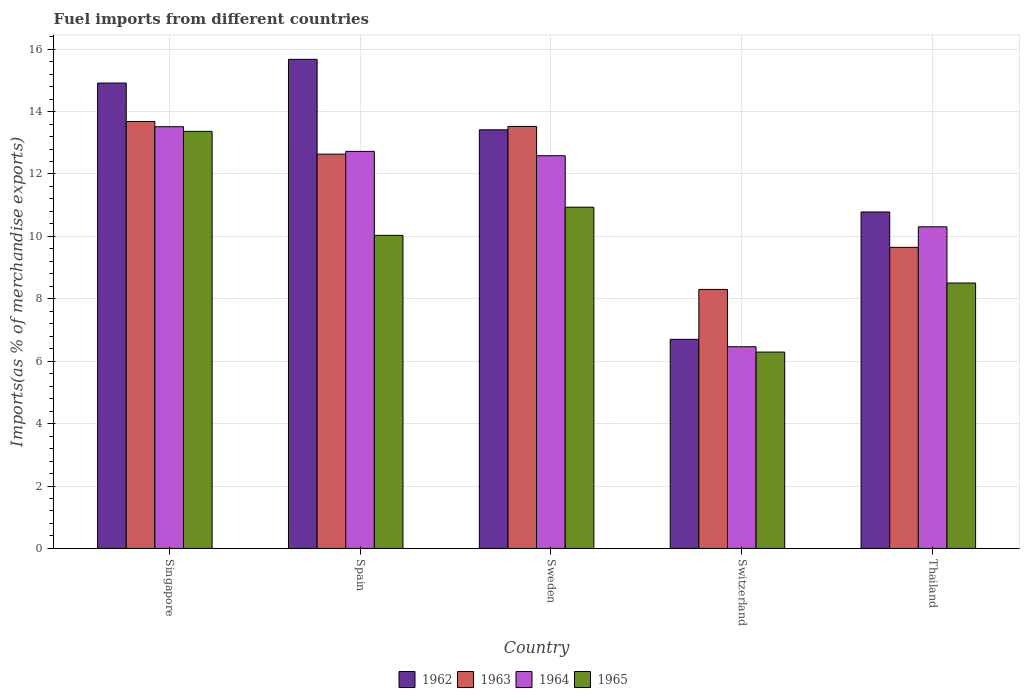How many bars are there on the 2nd tick from the left?
Provide a succinct answer. 4. How many bars are there on the 1st tick from the right?
Provide a succinct answer. 4. What is the label of the 5th group of bars from the left?
Provide a succinct answer. Thailand. What is the percentage of imports to different countries in 1963 in Switzerland?
Provide a succinct answer. 8.3. Across all countries, what is the maximum percentage of imports to different countries in 1965?
Make the answer very short. 13.37. Across all countries, what is the minimum percentage of imports to different countries in 1965?
Your response must be concise. 6.29. In which country was the percentage of imports to different countries in 1965 maximum?
Your response must be concise. Singapore. In which country was the percentage of imports to different countries in 1963 minimum?
Your answer should be compact. Switzerland. What is the total percentage of imports to different countries in 1962 in the graph?
Offer a very short reply. 61.48. What is the difference between the percentage of imports to different countries in 1965 in Switzerland and that in Thailand?
Your answer should be compact. -2.21. What is the difference between the percentage of imports to different countries in 1963 in Singapore and the percentage of imports to different countries in 1964 in Sweden?
Offer a very short reply. 1.1. What is the average percentage of imports to different countries in 1965 per country?
Provide a succinct answer. 9.83. What is the difference between the percentage of imports to different countries of/in 1964 and percentage of imports to different countries of/in 1965 in Spain?
Your answer should be very brief. 2.69. In how many countries, is the percentage of imports to different countries in 1962 greater than 10.8 %?
Provide a succinct answer. 3. What is the ratio of the percentage of imports to different countries in 1962 in Spain to that in Switzerland?
Provide a succinct answer. 2.34. Is the percentage of imports to different countries in 1962 in Sweden less than that in Thailand?
Your response must be concise. No. Is the difference between the percentage of imports to different countries in 1964 in Singapore and Switzerland greater than the difference between the percentage of imports to different countries in 1965 in Singapore and Switzerland?
Provide a succinct answer. No. What is the difference between the highest and the second highest percentage of imports to different countries in 1963?
Make the answer very short. 0.89. What is the difference between the highest and the lowest percentage of imports to different countries in 1962?
Give a very brief answer. 8.97. Is it the case that in every country, the sum of the percentage of imports to different countries in 1962 and percentage of imports to different countries in 1964 is greater than the sum of percentage of imports to different countries in 1965 and percentage of imports to different countries in 1963?
Offer a terse response. No. What does the 3rd bar from the left in Thailand represents?
Keep it short and to the point. 1964. Is it the case that in every country, the sum of the percentage of imports to different countries in 1964 and percentage of imports to different countries in 1965 is greater than the percentage of imports to different countries in 1962?
Give a very brief answer. Yes. How many bars are there?
Your answer should be very brief. 20. Are the values on the major ticks of Y-axis written in scientific E-notation?
Ensure brevity in your answer.  No. Does the graph contain grids?
Your answer should be very brief. Yes. Where does the legend appear in the graph?
Provide a short and direct response. Bottom center. What is the title of the graph?
Your response must be concise. Fuel imports from different countries. What is the label or title of the Y-axis?
Ensure brevity in your answer.  Imports(as % of merchandise exports). What is the Imports(as % of merchandise exports) in 1962 in Singapore?
Ensure brevity in your answer.  14.91. What is the Imports(as % of merchandise exports) in 1963 in Singapore?
Your answer should be very brief. 13.68. What is the Imports(as % of merchandise exports) of 1964 in Singapore?
Keep it short and to the point. 13.51. What is the Imports(as % of merchandise exports) of 1965 in Singapore?
Provide a short and direct response. 13.37. What is the Imports(as % of merchandise exports) of 1962 in Spain?
Provide a succinct answer. 15.67. What is the Imports(as % of merchandise exports) of 1963 in Spain?
Ensure brevity in your answer.  12.64. What is the Imports(as % of merchandise exports) of 1964 in Spain?
Make the answer very short. 12.72. What is the Imports(as % of merchandise exports) of 1965 in Spain?
Offer a very short reply. 10.03. What is the Imports(as % of merchandise exports) of 1962 in Sweden?
Offer a terse response. 13.42. What is the Imports(as % of merchandise exports) in 1963 in Sweden?
Your answer should be very brief. 13.52. What is the Imports(as % of merchandise exports) of 1964 in Sweden?
Keep it short and to the point. 12.58. What is the Imports(as % of merchandise exports) in 1965 in Sweden?
Offer a very short reply. 10.93. What is the Imports(as % of merchandise exports) in 1962 in Switzerland?
Provide a short and direct response. 6.7. What is the Imports(as % of merchandise exports) of 1963 in Switzerland?
Offer a terse response. 8.3. What is the Imports(as % of merchandise exports) of 1964 in Switzerland?
Your answer should be very brief. 6.46. What is the Imports(as % of merchandise exports) of 1965 in Switzerland?
Make the answer very short. 6.29. What is the Imports(as % of merchandise exports) in 1962 in Thailand?
Keep it short and to the point. 10.78. What is the Imports(as % of merchandise exports) of 1963 in Thailand?
Your answer should be compact. 9.65. What is the Imports(as % of merchandise exports) of 1964 in Thailand?
Provide a succinct answer. 10.31. What is the Imports(as % of merchandise exports) in 1965 in Thailand?
Give a very brief answer. 8.51. Across all countries, what is the maximum Imports(as % of merchandise exports) in 1962?
Ensure brevity in your answer.  15.67. Across all countries, what is the maximum Imports(as % of merchandise exports) of 1963?
Your response must be concise. 13.68. Across all countries, what is the maximum Imports(as % of merchandise exports) in 1964?
Ensure brevity in your answer.  13.51. Across all countries, what is the maximum Imports(as % of merchandise exports) in 1965?
Make the answer very short. 13.37. Across all countries, what is the minimum Imports(as % of merchandise exports) of 1962?
Your response must be concise. 6.7. Across all countries, what is the minimum Imports(as % of merchandise exports) of 1963?
Provide a short and direct response. 8.3. Across all countries, what is the minimum Imports(as % of merchandise exports) of 1964?
Provide a succinct answer. 6.46. Across all countries, what is the minimum Imports(as % of merchandise exports) in 1965?
Your response must be concise. 6.29. What is the total Imports(as % of merchandise exports) in 1962 in the graph?
Make the answer very short. 61.48. What is the total Imports(as % of merchandise exports) in 1963 in the graph?
Offer a very short reply. 57.79. What is the total Imports(as % of merchandise exports) of 1964 in the graph?
Your answer should be very brief. 55.59. What is the total Imports(as % of merchandise exports) in 1965 in the graph?
Your answer should be very brief. 49.13. What is the difference between the Imports(as % of merchandise exports) of 1962 in Singapore and that in Spain?
Provide a succinct answer. -0.76. What is the difference between the Imports(as % of merchandise exports) of 1963 in Singapore and that in Spain?
Offer a very short reply. 1.05. What is the difference between the Imports(as % of merchandise exports) in 1964 in Singapore and that in Spain?
Your response must be concise. 0.79. What is the difference between the Imports(as % of merchandise exports) in 1965 in Singapore and that in Spain?
Your response must be concise. 3.33. What is the difference between the Imports(as % of merchandise exports) in 1962 in Singapore and that in Sweden?
Offer a terse response. 1.5. What is the difference between the Imports(as % of merchandise exports) in 1963 in Singapore and that in Sweden?
Your answer should be compact. 0.16. What is the difference between the Imports(as % of merchandise exports) of 1964 in Singapore and that in Sweden?
Your answer should be compact. 0.93. What is the difference between the Imports(as % of merchandise exports) of 1965 in Singapore and that in Sweden?
Keep it short and to the point. 2.43. What is the difference between the Imports(as % of merchandise exports) in 1962 in Singapore and that in Switzerland?
Make the answer very short. 8.21. What is the difference between the Imports(as % of merchandise exports) of 1963 in Singapore and that in Switzerland?
Provide a succinct answer. 5.38. What is the difference between the Imports(as % of merchandise exports) in 1964 in Singapore and that in Switzerland?
Ensure brevity in your answer.  7.05. What is the difference between the Imports(as % of merchandise exports) in 1965 in Singapore and that in Switzerland?
Your answer should be very brief. 7.07. What is the difference between the Imports(as % of merchandise exports) of 1962 in Singapore and that in Thailand?
Offer a terse response. 4.13. What is the difference between the Imports(as % of merchandise exports) in 1963 in Singapore and that in Thailand?
Provide a succinct answer. 4.03. What is the difference between the Imports(as % of merchandise exports) of 1964 in Singapore and that in Thailand?
Give a very brief answer. 3.21. What is the difference between the Imports(as % of merchandise exports) of 1965 in Singapore and that in Thailand?
Keep it short and to the point. 4.86. What is the difference between the Imports(as % of merchandise exports) in 1962 in Spain and that in Sweden?
Keep it short and to the point. 2.26. What is the difference between the Imports(as % of merchandise exports) of 1963 in Spain and that in Sweden?
Your answer should be compact. -0.89. What is the difference between the Imports(as % of merchandise exports) of 1964 in Spain and that in Sweden?
Make the answer very short. 0.14. What is the difference between the Imports(as % of merchandise exports) in 1965 in Spain and that in Sweden?
Your response must be concise. -0.9. What is the difference between the Imports(as % of merchandise exports) of 1962 in Spain and that in Switzerland?
Make the answer very short. 8.97. What is the difference between the Imports(as % of merchandise exports) of 1963 in Spain and that in Switzerland?
Your response must be concise. 4.34. What is the difference between the Imports(as % of merchandise exports) of 1964 in Spain and that in Switzerland?
Your answer should be compact. 6.26. What is the difference between the Imports(as % of merchandise exports) of 1965 in Spain and that in Switzerland?
Your response must be concise. 3.74. What is the difference between the Imports(as % of merchandise exports) in 1962 in Spain and that in Thailand?
Your answer should be compact. 4.89. What is the difference between the Imports(as % of merchandise exports) of 1963 in Spain and that in Thailand?
Give a very brief answer. 2.99. What is the difference between the Imports(as % of merchandise exports) in 1964 in Spain and that in Thailand?
Provide a short and direct response. 2.42. What is the difference between the Imports(as % of merchandise exports) in 1965 in Spain and that in Thailand?
Provide a succinct answer. 1.53. What is the difference between the Imports(as % of merchandise exports) in 1962 in Sweden and that in Switzerland?
Keep it short and to the point. 6.72. What is the difference between the Imports(as % of merchandise exports) of 1963 in Sweden and that in Switzerland?
Keep it short and to the point. 5.22. What is the difference between the Imports(as % of merchandise exports) of 1964 in Sweden and that in Switzerland?
Ensure brevity in your answer.  6.12. What is the difference between the Imports(as % of merchandise exports) in 1965 in Sweden and that in Switzerland?
Ensure brevity in your answer.  4.64. What is the difference between the Imports(as % of merchandise exports) in 1962 in Sweden and that in Thailand?
Provide a short and direct response. 2.63. What is the difference between the Imports(as % of merchandise exports) of 1963 in Sweden and that in Thailand?
Your answer should be compact. 3.88. What is the difference between the Imports(as % of merchandise exports) of 1964 in Sweden and that in Thailand?
Offer a terse response. 2.28. What is the difference between the Imports(as % of merchandise exports) of 1965 in Sweden and that in Thailand?
Ensure brevity in your answer.  2.43. What is the difference between the Imports(as % of merchandise exports) of 1962 in Switzerland and that in Thailand?
Provide a succinct answer. -4.08. What is the difference between the Imports(as % of merchandise exports) of 1963 in Switzerland and that in Thailand?
Make the answer very short. -1.35. What is the difference between the Imports(as % of merchandise exports) of 1964 in Switzerland and that in Thailand?
Your answer should be very brief. -3.84. What is the difference between the Imports(as % of merchandise exports) of 1965 in Switzerland and that in Thailand?
Your answer should be compact. -2.21. What is the difference between the Imports(as % of merchandise exports) of 1962 in Singapore and the Imports(as % of merchandise exports) of 1963 in Spain?
Your response must be concise. 2.28. What is the difference between the Imports(as % of merchandise exports) of 1962 in Singapore and the Imports(as % of merchandise exports) of 1964 in Spain?
Your response must be concise. 2.19. What is the difference between the Imports(as % of merchandise exports) in 1962 in Singapore and the Imports(as % of merchandise exports) in 1965 in Spain?
Ensure brevity in your answer.  4.88. What is the difference between the Imports(as % of merchandise exports) in 1963 in Singapore and the Imports(as % of merchandise exports) in 1964 in Spain?
Ensure brevity in your answer.  0.96. What is the difference between the Imports(as % of merchandise exports) of 1963 in Singapore and the Imports(as % of merchandise exports) of 1965 in Spain?
Ensure brevity in your answer.  3.65. What is the difference between the Imports(as % of merchandise exports) in 1964 in Singapore and the Imports(as % of merchandise exports) in 1965 in Spain?
Provide a succinct answer. 3.48. What is the difference between the Imports(as % of merchandise exports) of 1962 in Singapore and the Imports(as % of merchandise exports) of 1963 in Sweden?
Your answer should be very brief. 1.39. What is the difference between the Imports(as % of merchandise exports) of 1962 in Singapore and the Imports(as % of merchandise exports) of 1964 in Sweden?
Your response must be concise. 2.33. What is the difference between the Imports(as % of merchandise exports) in 1962 in Singapore and the Imports(as % of merchandise exports) in 1965 in Sweden?
Offer a terse response. 3.98. What is the difference between the Imports(as % of merchandise exports) of 1963 in Singapore and the Imports(as % of merchandise exports) of 1964 in Sweden?
Give a very brief answer. 1.1. What is the difference between the Imports(as % of merchandise exports) in 1963 in Singapore and the Imports(as % of merchandise exports) in 1965 in Sweden?
Make the answer very short. 2.75. What is the difference between the Imports(as % of merchandise exports) of 1964 in Singapore and the Imports(as % of merchandise exports) of 1965 in Sweden?
Your answer should be compact. 2.58. What is the difference between the Imports(as % of merchandise exports) in 1962 in Singapore and the Imports(as % of merchandise exports) in 1963 in Switzerland?
Your response must be concise. 6.61. What is the difference between the Imports(as % of merchandise exports) of 1962 in Singapore and the Imports(as % of merchandise exports) of 1964 in Switzerland?
Provide a succinct answer. 8.45. What is the difference between the Imports(as % of merchandise exports) in 1962 in Singapore and the Imports(as % of merchandise exports) in 1965 in Switzerland?
Your response must be concise. 8.62. What is the difference between the Imports(as % of merchandise exports) of 1963 in Singapore and the Imports(as % of merchandise exports) of 1964 in Switzerland?
Offer a very short reply. 7.22. What is the difference between the Imports(as % of merchandise exports) in 1963 in Singapore and the Imports(as % of merchandise exports) in 1965 in Switzerland?
Ensure brevity in your answer.  7.39. What is the difference between the Imports(as % of merchandise exports) in 1964 in Singapore and the Imports(as % of merchandise exports) in 1965 in Switzerland?
Offer a terse response. 7.22. What is the difference between the Imports(as % of merchandise exports) in 1962 in Singapore and the Imports(as % of merchandise exports) in 1963 in Thailand?
Offer a terse response. 5.27. What is the difference between the Imports(as % of merchandise exports) in 1962 in Singapore and the Imports(as % of merchandise exports) in 1964 in Thailand?
Your answer should be very brief. 4.61. What is the difference between the Imports(as % of merchandise exports) of 1962 in Singapore and the Imports(as % of merchandise exports) of 1965 in Thailand?
Your answer should be very brief. 6.41. What is the difference between the Imports(as % of merchandise exports) in 1963 in Singapore and the Imports(as % of merchandise exports) in 1964 in Thailand?
Offer a very short reply. 3.37. What is the difference between the Imports(as % of merchandise exports) of 1963 in Singapore and the Imports(as % of merchandise exports) of 1965 in Thailand?
Provide a succinct answer. 5.18. What is the difference between the Imports(as % of merchandise exports) of 1964 in Singapore and the Imports(as % of merchandise exports) of 1965 in Thailand?
Your answer should be very brief. 5.01. What is the difference between the Imports(as % of merchandise exports) of 1962 in Spain and the Imports(as % of merchandise exports) of 1963 in Sweden?
Provide a succinct answer. 2.15. What is the difference between the Imports(as % of merchandise exports) of 1962 in Spain and the Imports(as % of merchandise exports) of 1964 in Sweden?
Provide a succinct answer. 3.09. What is the difference between the Imports(as % of merchandise exports) in 1962 in Spain and the Imports(as % of merchandise exports) in 1965 in Sweden?
Ensure brevity in your answer.  4.74. What is the difference between the Imports(as % of merchandise exports) in 1963 in Spain and the Imports(as % of merchandise exports) in 1964 in Sweden?
Ensure brevity in your answer.  0.05. What is the difference between the Imports(as % of merchandise exports) in 1963 in Spain and the Imports(as % of merchandise exports) in 1965 in Sweden?
Provide a short and direct response. 1.7. What is the difference between the Imports(as % of merchandise exports) in 1964 in Spain and the Imports(as % of merchandise exports) in 1965 in Sweden?
Ensure brevity in your answer.  1.79. What is the difference between the Imports(as % of merchandise exports) in 1962 in Spain and the Imports(as % of merchandise exports) in 1963 in Switzerland?
Keep it short and to the point. 7.37. What is the difference between the Imports(as % of merchandise exports) of 1962 in Spain and the Imports(as % of merchandise exports) of 1964 in Switzerland?
Offer a very short reply. 9.21. What is the difference between the Imports(as % of merchandise exports) of 1962 in Spain and the Imports(as % of merchandise exports) of 1965 in Switzerland?
Ensure brevity in your answer.  9.38. What is the difference between the Imports(as % of merchandise exports) of 1963 in Spain and the Imports(as % of merchandise exports) of 1964 in Switzerland?
Ensure brevity in your answer.  6.17. What is the difference between the Imports(as % of merchandise exports) of 1963 in Spain and the Imports(as % of merchandise exports) of 1965 in Switzerland?
Ensure brevity in your answer.  6.34. What is the difference between the Imports(as % of merchandise exports) of 1964 in Spain and the Imports(as % of merchandise exports) of 1965 in Switzerland?
Ensure brevity in your answer.  6.43. What is the difference between the Imports(as % of merchandise exports) of 1962 in Spain and the Imports(as % of merchandise exports) of 1963 in Thailand?
Provide a short and direct response. 6.03. What is the difference between the Imports(as % of merchandise exports) in 1962 in Spain and the Imports(as % of merchandise exports) in 1964 in Thailand?
Ensure brevity in your answer.  5.37. What is the difference between the Imports(as % of merchandise exports) in 1962 in Spain and the Imports(as % of merchandise exports) in 1965 in Thailand?
Provide a short and direct response. 7.17. What is the difference between the Imports(as % of merchandise exports) in 1963 in Spain and the Imports(as % of merchandise exports) in 1964 in Thailand?
Give a very brief answer. 2.33. What is the difference between the Imports(as % of merchandise exports) in 1963 in Spain and the Imports(as % of merchandise exports) in 1965 in Thailand?
Ensure brevity in your answer.  4.13. What is the difference between the Imports(as % of merchandise exports) in 1964 in Spain and the Imports(as % of merchandise exports) in 1965 in Thailand?
Your answer should be compact. 4.22. What is the difference between the Imports(as % of merchandise exports) in 1962 in Sweden and the Imports(as % of merchandise exports) in 1963 in Switzerland?
Offer a terse response. 5.12. What is the difference between the Imports(as % of merchandise exports) of 1962 in Sweden and the Imports(as % of merchandise exports) of 1964 in Switzerland?
Make the answer very short. 6.95. What is the difference between the Imports(as % of merchandise exports) of 1962 in Sweden and the Imports(as % of merchandise exports) of 1965 in Switzerland?
Keep it short and to the point. 7.12. What is the difference between the Imports(as % of merchandise exports) in 1963 in Sweden and the Imports(as % of merchandise exports) in 1964 in Switzerland?
Make the answer very short. 7.06. What is the difference between the Imports(as % of merchandise exports) of 1963 in Sweden and the Imports(as % of merchandise exports) of 1965 in Switzerland?
Give a very brief answer. 7.23. What is the difference between the Imports(as % of merchandise exports) in 1964 in Sweden and the Imports(as % of merchandise exports) in 1965 in Switzerland?
Keep it short and to the point. 6.29. What is the difference between the Imports(as % of merchandise exports) in 1962 in Sweden and the Imports(as % of merchandise exports) in 1963 in Thailand?
Offer a very short reply. 3.77. What is the difference between the Imports(as % of merchandise exports) in 1962 in Sweden and the Imports(as % of merchandise exports) in 1964 in Thailand?
Provide a short and direct response. 3.11. What is the difference between the Imports(as % of merchandise exports) of 1962 in Sweden and the Imports(as % of merchandise exports) of 1965 in Thailand?
Keep it short and to the point. 4.91. What is the difference between the Imports(as % of merchandise exports) in 1963 in Sweden and the Imports(as % of merchandise exports) in 1964 in Thailand?
Make the answer very short. 3.22. What is the difference between the Imports(as % of merchandise exports) in 1963 in Sweden and the Imports(as % of merchandise exports) in 1965 in Thailand?
Keep it short and to the point. 5.02. What is the difference between the Imports(as % of merchandise exports) in 1964 in Sweden and the Imports(as % of merchandise exports) in 1965 in Thailand?
Keep it short and to the point. 4.08. What is the difference between the Imports(as % of merchandise exports) in 1962 in Switzerland and the Imports(as % of merchandise exports) in 1963 in Thailand?
Keep it short and to the point. -2.95. What is the difference between the Imports(as % of merchandise exports) of 1962 in Switzerland and the Imports(as % of merchandise exports) of 1964 in Thailand?
Provide a succinct answer. -3.61. What is the difference between the Imports(as % of merchandise exports) of 1962 in Switzerland and the Imports(as % of merchandise exports) of 1965 in Thailand?
Offer a terse response. -1.81. What is the difference between the Imports(as % of merchandise exports) in 1963 in Switzerland and the Imports(as % of merchandise exports) in 1964 in Thailand?
Provide a short and direct response. -2.01. What is the difference between the Imports(as % of merchandise exports) of 1963 in Switzerland and the Imports(as % of merchandise exports) of 1965 in Thailand?
Ensure brevity in your answer.  -0.21. What is the difference between the Imports(as % of merchandise exports) in 1964 in Switzerland and the Imports(as % of merchandise exports) in 1965 in Thailand?
Your answer should be compact. -2.04. What is the average Imports(as % of merchandise exports) of 1962 per country?
Make the answer very short. 12.3. What is the average Imports(as % of merchandise exports) in 1963 per country?
Ensure brevity in your answer.  11.56. What is the average Imports(as % of merchandise exports) of 1964 per country?
Provide a short and direct response. 11.12. What is the average Imports(as % of merchandise exports) of 1965 per country?
Offer a very short reply. 9.83. What is the difference between the Imports(as % of merchandise exports) of 1962 and Imports(as % of merchandise exports) of 1963 in Singapore?
Make the answer very short. 1.23. What is the difference between the Imports(as % of merchandise exports) of 1962 and Imports(as % of merchandise exports) of 1964 in Singapore?
Your answer should be compact. 1.4. What is the difference between the Imports(as % of merchandise exports) in 1962 and Imports(as % of merchandise exports) in 1965 in Singapore?
Ensure brevity in your answer.  1.55. What is the difference between the Imports(as % of merchandise exports) of 1963 and Imports(as % of merchandise exports) of 1964 in Singapore?
Keep it short and to the point. 0.17. What is the difference between the Imports(as % of merchandise exports) in 1963 and Imports(as % of merchandise exports) in 1965 in Singapore?
Give a very brief answer. 0.32. What is the difference between the Imports(as % of merchandise exports) in 1964 and Imports(as % of merchandise exports) in 1965 in Singapore?
Give a very brief answer. 0.15. What is the difference between the Imports(as % of merchandise exports) in 1962 and Imports(as % of merchandise exports) in 1963 in Spain?
Keep it short and to the point. 3.04. What is the difference between the Imports(as % of merchandise exports) in 1962 and Imports(as % of merchandise exports) in 1964 in Spain?
Your answer should be compact. 2.95. What is the difference between the Imports(as % of merchandise exports) in 1962 and Imports(as % of merchandise exports) in 1965 in Spain?
Give a very brief answer. 5.64. What is the difference between the Imports(as % of merchandise exports) in 1963 and Imports(as % of merchandise exports) in 1964 in Spain?
Provide a short and direct response. -0.09. What is the difference between the Imports(as % of merchandise exports) in 1963 and Imports(as % of merchandise exports) in 1965 in Spain?
Offer a terse response. 2.6. What is the difference between the Imports(as % of merchandise exports) of 1964 and Imports(as % of merchandise exports) of 1965 in Spain?
Make the answer very short. 2.69. What is the difference between the Imports(as % of merchandise exports) of 1962 and Imports(as % of merchandise exports) of 1963 in Sweden?
Make the answer very short. -0.11. What is the difference between the Imports(as % of merchandise exports) of 1962 and Imports(as % of merchandise exports) of 1964 in Sweden?
Offer a terse response. 0.83. What is the difference between the Imports(as % of merchandise exports) of 1962 and Imports(as % of merchandise exports) of 1965 in Sweden?
Provide a succinct answer. 2.48. What is the difference between the Imports(as % of merchandise exports) in 1963 and Imports(as % of merchandise exports) in 1964 in Sweden?
Your answer should be compact. 0.94. What is the difference between the Imports(as % of merchandise exports) of 1963 and Imports(as % of merchandise exports) of 1965 in Sweden?
Your answer should be very brief. 2.59. What is the difference between the Imports(as % of merchandise exports) in 1964 and Imports(as % of merchandise exports) in 1965 in Sweden?
Your answer should be compact. 1.65. What is the difference between the Imports(as % of merchandise exports) in 1962 and Imports(as % of merchandise exports) in 1963 in Switzerland?
Make the answer very short. -1.6. What is the difference between the Imports(as % of merchandise exports) of 1962 and Imports(as % of merchandise exports) of 1964 in Switzerland?
Offer a very short reply. 0.24. What is the difference between the Imports(as % of merchandise exports) in 1962 and Imports(as % of merchandise exports) in 1965 in Switzerland?
Provide a succinct answer. 0.41. What is the difference between the Imports(as % of merchandise exports) of 1963 and Imports(as % of merchandise exports) of 1964 in Switzerland?
Your answer should be very brief. 1.84. What is the difference between the Imports(as % of merchandise exports) of 1963 and Imports(as % of merchandise exports) of 1965 in Switzerland?
Offer a terse response. 2.01. What is the difference between the Imports(as % of merchandise exports) of 1964 and Imports(as % of merchandise exports) of 1965 in Switzerland?
Provide a succinct answer. 0.17. What is the difference between the Imports(as % of merchandise exports) of 1962 and Imports(as % of merchandise exports) of 1963 in Thailand?
Keep it short and to the point. 1.13. What is the difference between the Imports(as % of merchandise exports) in 1962 and Imports(as % of merchandise exports) in 1964 in Thailand?
Your response must be concise. 0.48. What is the difference between the Imports(as % of merchandise exports) in 1962 and Imports(as % of merchandise exports) in 1965 in Thailand?
Give a very brief answer. 2.28. What is the difference between the Imports(as % of merchandise exports) of 1963 and Imports(as % of merchandise exports) of 1964 in Thailand?
Your answer should be very brief. -0.66. What is the difference between the Imports(as % of merchandise exports) in 1963 and Imports(as % of merchandise exports) in 1965 in Thailand?
Make the answer very short. 1.14. What is the difference between the Imports(as % of merchandise exports) in 1964 and Imports(as % of merchandise exports) in 1965 in Thailand?
Make the answer very short. 1.8. What is the ratio of the Imports(as % of merchandise exports) in 1962 in Singapore to that in Spain?
Ensure brevity in your answer.  0.95. What is the ratio of the Imports(as % of merchandise exports) in 1963 in Singapore to that in Spain?
Give a very brief answer. 1.08. What is the ratio of the Imports(as % of merchandise exports) in 1964 in Singapore to that in Spain?
Provide a short and direct response. 1.06. What is the ratio of the Imports(as % of merchandise exports) in 1965 in Singapore to that in Spain?
Keep it short and to the point. 1.33. What is the ratio of the Imports(as % of merchandise exports) in 1962 in Singapore to that in Sweden?
Provide a short and direct response. 1.11. What is the ratio of the Imports(as % of merchandise exports) of 1963 in Singapore to that in Sweden?
Your answer should be compact. 1.01. What is the ratio of the Imports(as % of merchandise exports) in 1964 in Singapore to that in Sweden?
Give a very brief answer. 1.07. What is the ratio of the Imports(as % of merchandise exports) of 1965 in Singapore to that in Sweden?
Your answer should be very brief. 1.22. What is the ratio of the Imports(as % of merchandise exports) of 1962 in Singapore to that in Switzerland?
Provide a succinct answer. 2.23. What is the ratio of the Imports(as % of merchandise exports) of 1963 in Singapore to that in Switzerland?
Provide a short and direct response. 1.65. What is the ratio of the Imports(as % of merchandise exports) of 1964 in Singapore to that in Switzerland?
Provide a succinct answer. 2.09. What is the ratio of the Imports(as % of merchandise exports) of 1965 in Singapore to that in Switzerland?
Provide a short and direct response. 2.12. What is the ratio of the Imports(as % of merchandise exports) in 1962 in Singapore to that in Thailand?
Give a very brief answer. 1.38. What is the ratio of the Imports(as % of merchandise exports) in 1963 in Singapore to that in Thailand?
Your answer should be very brief. 1.42. What is the ratio of the Imports(as % of merchandise exports) in 1964 in Singapore to that in Thailand?
Offer a very short reply. 1.31. What is the ratio of the Imports(as % of merchandise exports) of 1965 in Singapore to that in Thailand?
Your response must be concise. 1.57. What is the ratio of the Imports(as % of merchandise exports) of 1962 in Spain to that in Sweden?
Provide a short and direct response. 1.17. What is the ratio of the Imports(as % of merchandise exports) in 1963 in Spain to that in Sweden?
Provide a short and direct response. 0.93. What is the ratio of the Imports(as % of merchandise exports) of 1965 in Spain to that in Sweden?
Make the answer very short. 0.92. What is the ratio of the Imports(as % of merchandise exports) of 1962 in Spain to that in Switzerland?
Your answer should be compact. 2.34. What is the ratio of the Imports(as % of merchandise exports) in 1963 in Spain to that in Switzerland?
Offer a terse response. 1.52. What is the ratio of the Imports(as % of merchandise exports) of 1964 in Spain to that in Switzerland?
Give a very brief answer. 1.97. What is the ratio of the Imports(as % of merchandise exports) of 1965 in Spain to that in Switzerland?
Offer a terse response. 1.59. What is the ratio of the Imports(as % of merchandise exports) of 1962 in Spain to that in Thailand?
Your response must be concise. 1.45. What is the ratio of the Imports(as % of merchandise exports) of 1963 in Spain to that in Thailand?
Your response must be concise. 1.31. What is the ratio of the Imports(as % of merchandise exports) of 1964 in Spain to that in Thailand?
Your answer should be very brief. 1.23. What is the ratio of the Imports(as % of merchandise exports) of 1965 in Spain to that in Thailand?
Your answer should be compact. 1.18. What is the ratio of the Imports(as % of merchandise exports) of 1962 in Sweden to that in Switzerland?
Offer a terse response. 2. What is the ratio of the Imports(as % of merchandise exports) of 1963 in Sweden to that in Switzerland?
Offer a very short reply. 1.63. What is the ratio of the Imports(as % of merchandise exports) in 1964 in Sweden to that in Switzerland?
Ensure brevity in your answer.  1.95. What is the ratio of the Imports(as % of merchandise exports) in 1965 in Sweden to that in Switzerland?
Ensure brevity in your answer.  1.74. What is the ratio of the Imports(as % of merchandise exports) in 1962 in Sweden to that in Thailand?
Give a very brief answer. 1.24. What is the ratio of the Imports(as % of merchandise exports) of 1963 in Sweden to that in Thailand?
Provide a succinct answer. 1.4. What is the ratio of the Imports(as % of merchandise exports) of 1964 in Sweden to that in Thailand?
Your response must be concise. 1.22. What is the ratio of the Imports(as % of merchandise exports) in 1965 in Sweden to that in Thailand?
Your answer should be compact. 1.29. What is the ratio of the Imports(as % of merchandise exports) in 1962 in Switzerland to that in Thailand?
Provide a short and direct response. 0.62. What is the ratio of the Imports(as % of merchandise exports) in 1963 in Switzerland to that in Thailand?
Offer a terse response. 0.86. What is the ratio of the Imports(as % of merchandise exports) of 1964 in Switzerland to that in Thailand?
Give a very brief answer. 0.63. What is the ratio of the Imports(as % of merchandise exports) of 1965 in Switzerland to that in Thailand?
Your response must be concise. 0.74. What is the difference between the highest and the second highest Imports(as % of merchandise exports) of 1962?
Offer a terse response. 0.76. What is the difference between the highest and the second highest Imports(as % of merchandise exports) in 1963?
Keep it short and to the point. 0.16. What is the difference between the highest and the second highest Imports(as % of merchandise exports) of 1964?
Your answer should be very brief. 0.79. What is the difference between the highest and the second highest Imports(as % of merchandise exports) in 1965?
Offer a very short reply. 2.43. What is the difference between the highest and the lowest Imports(as % of merchandise exports) in 1962?
Your answer should be very brief. 8.97. What is the difference between the highest and the lowest Imports(as % of merchandise exports) in 1963?
Give a very brief answer. 5.38. What is the difference between the highest and the lowest Imports(as % of merchandise exports) of 1964?
Offer a very short reply. 7.05. What is the difference between the highest and the lowest Imports(as % of merchandise exports) of 1965?
Your response must be concise. 7.07. 